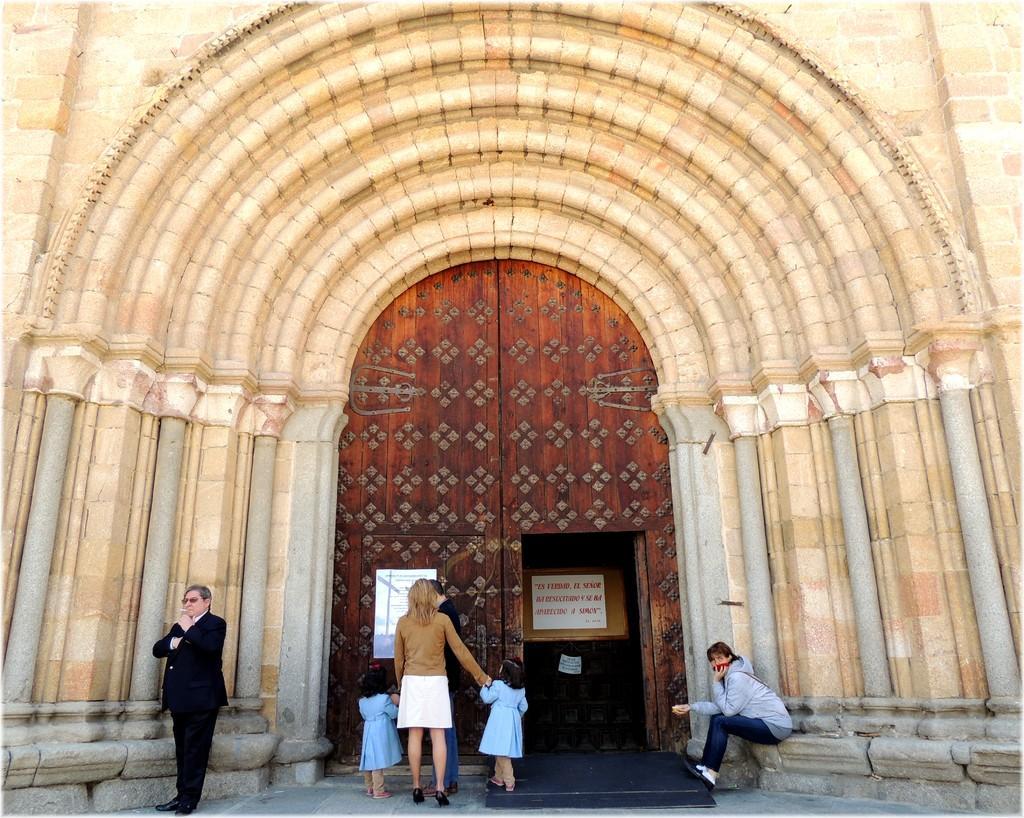Describe this image in one or two sentences. In this picture we can see some people are standing and a person is sitting. In front of the people there is a wall and a big wooden door and on the door there is a poster. 